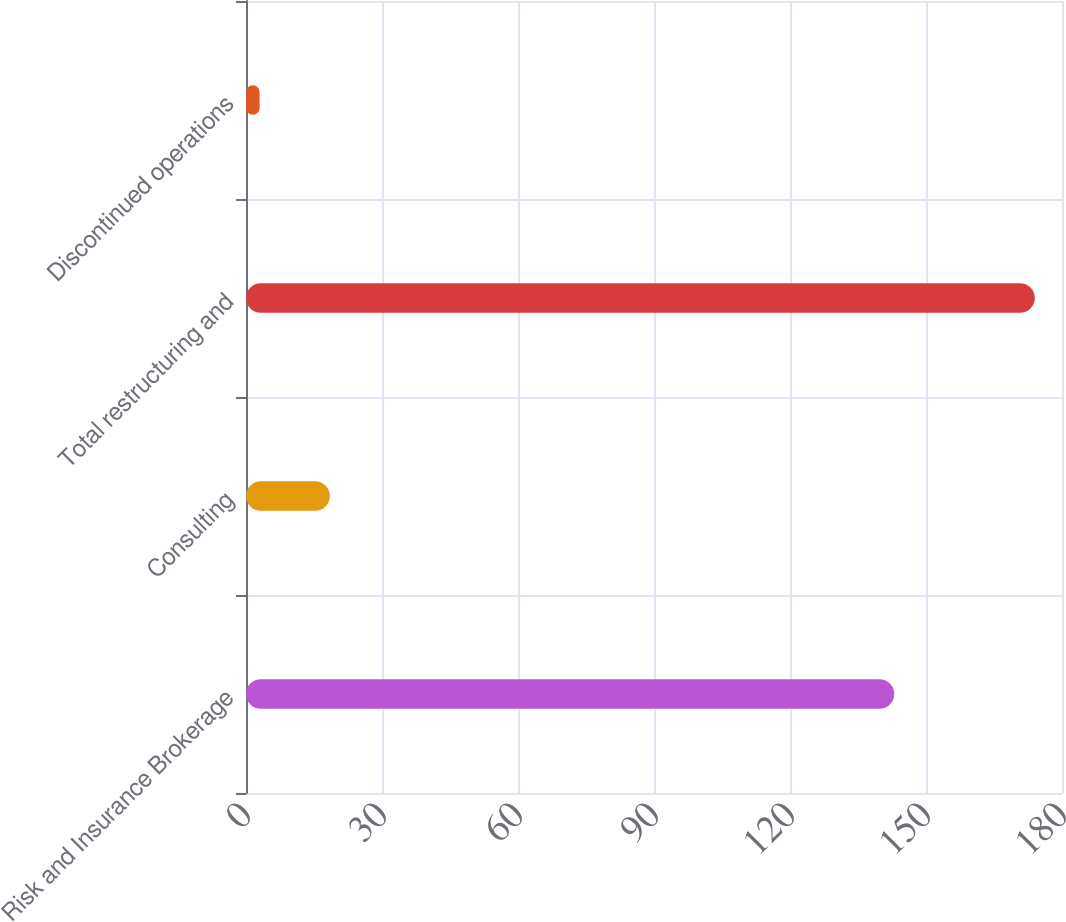Convert chart to OTSL. <chart><loc_0><loc_0><loc_500><loc_500><bar_chart><fcel>Risk and Insurance Brokerage<fcel>Consulting<fcel>Total restructuring and<fcel>Discontinued operations<nl><fcel>143<fcel>18.5<fcel>174<fcel>3<nl></chart> 